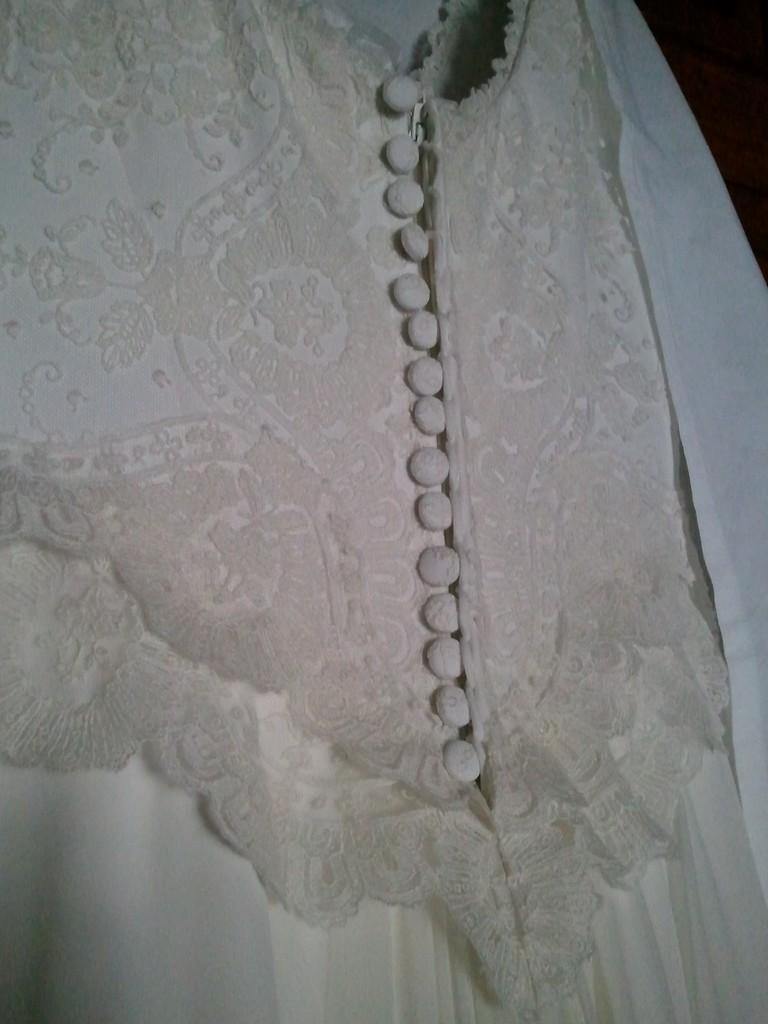What type of clothing is in the image? There is a dress in the image. What color is the dress? The dress is white in color. How many legs does the dress have in the image? The dress does not have legs, as it is an inanimate object. 